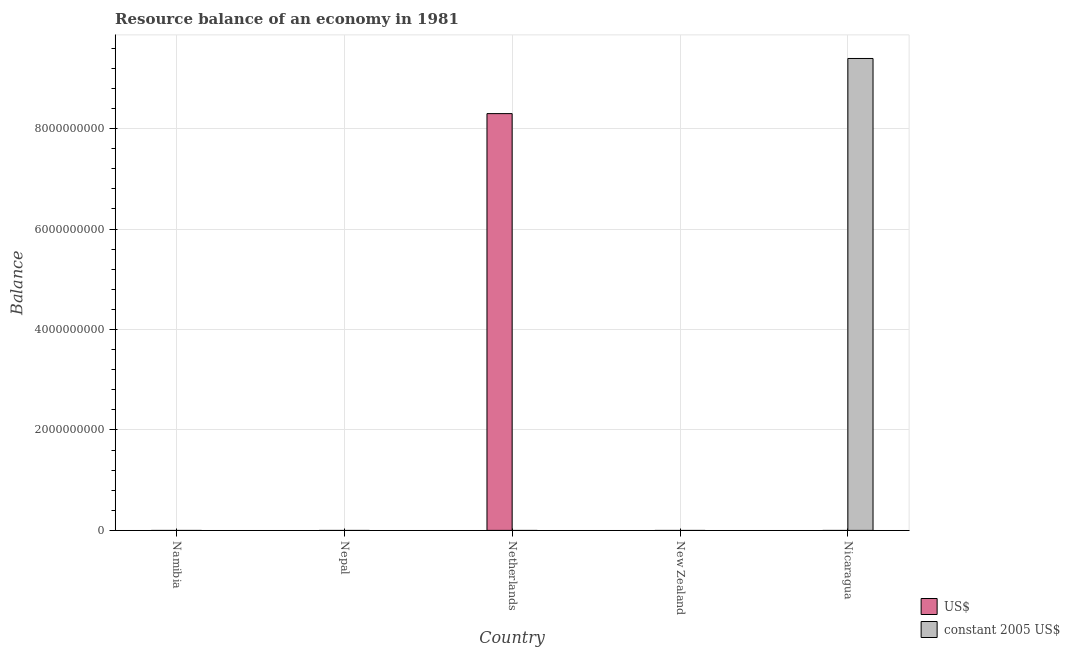Are the number of bars per tick equal to the number of legend labels?
Keep it short and to the point. No. How many bars are there on the 3rd tick from the left?
Provide a short and direct response. 1. What is the label of the 1st group of bars from the left?
Offer a very short reply. Namibia. In how many cases, is the number of bars for a given country not equal to the number of legend labels?
Your answer should be very brief. 5. What is the resource balance in constant us$ in Nicaragua?
Your answer should be very brief. 9.40e+09. Across all countries, what is the maximum resource balance in constant us$?
Ensure brevity in your answer.  9.40e+09. What is the total resource balance in us$ in the graph?
Make the answer very short. 8.30e+09. What is the average resource balance in constant us$ per country?
Give a very brief answer. 1.88e+09. In how many countries, is the resource balance in constant us$ greater than 7200000000 units?
Give a very brief answer. 1. What is the difference between the highest and the lowest resource balance in constant us$?
Give a very brief answer. 9.40e+09. Does the graph contain any zero values?
Offer a very short reply. Yes. Does the graph contain grids?
Your answer should be very brief. Yes. How are the legend labels stacked?
Your response must be concise. Vertical. What is the title of the graph?
Your response must be concise. Resource balance of an economy in 1981. Does "GDP" appear as one of the legend labels in the graph?
Your response must be concise. No. What is the label or title of the Y-axis?
Your response must be concise. Balance. What is the Balance in constant 2005 US$ in Nepal?
Offer a very short reply. 0. What is the Balance of US$ in Netherlands?
Ensure brevity in your answer.  8.30e+09. What is the Balance of constant 2005 US$ in Netherlands?
Ensure brevity in your answer.  0. What is the Balance of constant 2005 US$ in New Zealand?
Your response must be concise. 0. What is the Balance in US$ in Nicaragua?
Offer a terse response. 0. What is the Balance in constant 2005 US$ in Nicaragua?
Offer a very short reply. 9.40e+09. Across all countries, what is the maximum Balance in US$?
Your answer should be compact. 8.30e+09. Across all countries, what is the maximum Balance in constant 2005 US$?
Offer a terse response. 9.40e+09. Across all countries, what is the minimum Balance of constant 2005 US$?
Your answer should be very brief. 0. What is the total Balance in US$ in the graph?
Provide a succinct answer. 8.30e+09. What is the total Balance of constant 2005 US$ in the graph?
Keep it short and to the point. 9.40e+09. What is the difference between the Balance of US$ in Netherlands and the Balance of constant 2005 US$ in Nicaragua?
Your answer should be compact. -1.10e+09. What is the average Balance in US$ per country?
Provide a short and direct response. 1.66e+09. What is the average Balance of constant 2005 US$ per country?
Give a very brief answer. 1.88e+09. What is the difference between the highest and the lowest Balance of US$?
Your answer should be compact. 8.30e+09. What is the difference between the highest and the lowest Balance in constant 2005 US$?
Your answer should be very brief. 9.40e+09. 